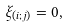<formula> <loc_0><loc_0><loc_500><loc_500>\xi _ { ( i ; j ) } = 0 ,</formula> 